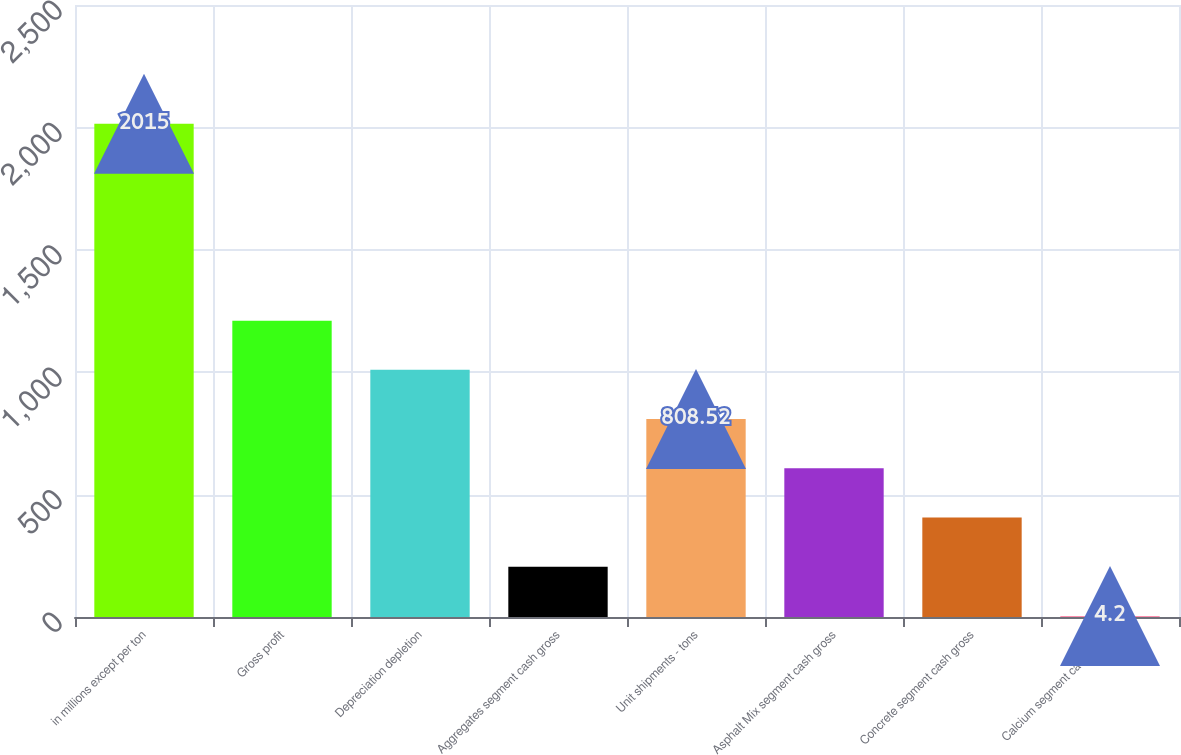Convert chart to OTSL. <chart><loc_0><loc_0><loc_500><loc_500><bar_chart><fcel>in millions except per ton<fcel>Gross profit<fcel>Depreciation depletion<fcel>Aggregates segment cash gross<fcel>Unit shipments - tons<fcel>Asphalt Mix segment cash gross<fcel>Concrete segment cash gross<fcel>Calcium segment cash gross<nl><fcel>2015<fcel>1210.68<fcel>1009.6<fcel>205.28<fcel>808.52<fcel>607.44<fcel>406.36<fcel>4.2<nl></chart> 